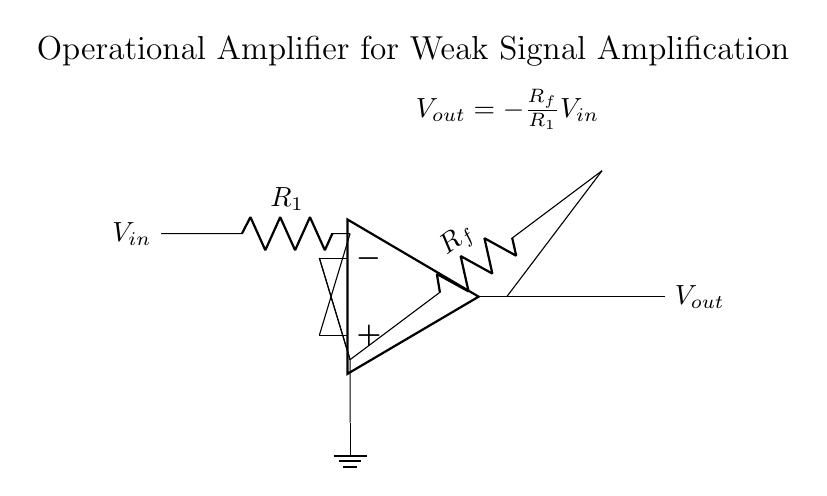What is the input voltage in this circuit? The input voltage is represented by \( V_{in} \), which is indicated on the left side of the circuit diagram.
Answer: \( V_{in} \) What type of circuit is this? This circuit is an operational amplifier circuit designed for amplifying weak signals, as stated in the title of the diagram.
Answer: Operational amplifier What is the value of the feedback resistor labeled \( R_f \)? The feedback resistor \( R_f \) is labeled in the circuit diagram, denoting its position for feedback from the output back to the inverting input of the op-amp.
Answer: \( R_f \) How is the output voltage related to the input voltage? The output voltage \( V_{out} \) is expressed by the equation \( V_{out} = -\frac{R_f}{R_1}V_{in} \), which demonstrates the relationship between the input and output considering the resistor values \( R_f \) and \( R_1 \).
Answer: \( V_{out} = -\frac{R_f}{R_1}V_{in} \) What role does the ground play in this circuit? The ground provides a reference point for the circuit, ensuring both stability and a common return path for current, which can be seen at the bottom of the inverting input connection in the diagram.
Answer: Reference point What happens to the output if \( R_1 \) is doubled? Doubling \( R_1 \) will halve the output voltage \( V_{out} \), as seen in the equation \( V_{out} = -\frac{R_f}{R_1}V_{in} \), reflecting an inverse relationship between \( R_1 \) and \( V_{out} \).
Answer: Halved 